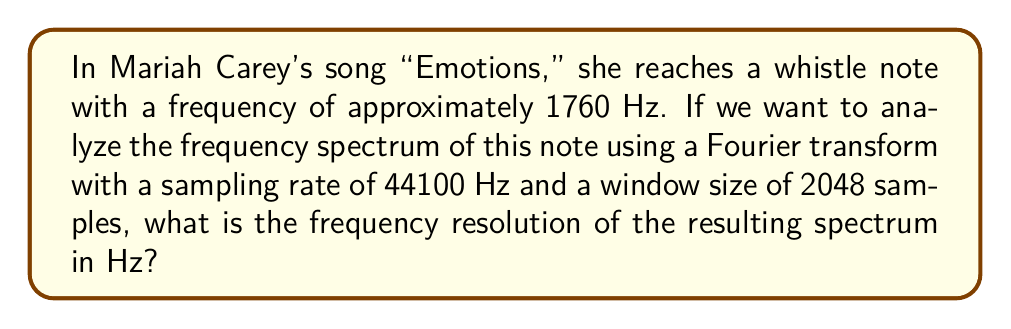Teach me how to tackle this problem. To solve this problem, we need to understand the relationship between the sampling rate, window size, and frequency resolution in a Fourier transform analysis. Let's break it down step-by-step:

1. The frequency resolution (Δf) in a Fourier transform is given by the formula:

   $$\Delta f = \frac{f_s}{N}$$

   where $f_s$ is the sampling rate and $N$ is the window size (number of samples).

2. We are given:
   - Sampling rate ($f_s$) = 44100 Hz
   - Window size ($N$) = 2048 samples

3. Let's substitute these values into the formula:

   $$\Delta f = \frac{44100 \text{ Hz}}{2048}$$

4. Now, let's perform the division:

   $$\Delta f = 21.533203125 \text{ Hz}$$

This means that each bin in the resulting frequency spectrum will represent a range of approximately 21.53 Hz.

5. We can round this to two decimal places for a more practical representation:

   $$\Delta f \approx 21.53 \text{ Hz}$$

This frequency resolution allows us to analyze Mariah Carey's whistle register with reasonable accuracy, as it's much smaller than the typical frequency range of whistle notes (usually between 1000 Hz and 4000 Hz).
Answer: 21.53 Hz 